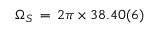Convert formula to latex. <formula><loc_0><loc_0><loc_500><loc_500>\Omega _ { S } \, = \, 2 \pi \times 3 8 . 4 0 ( 6 )</formula> 